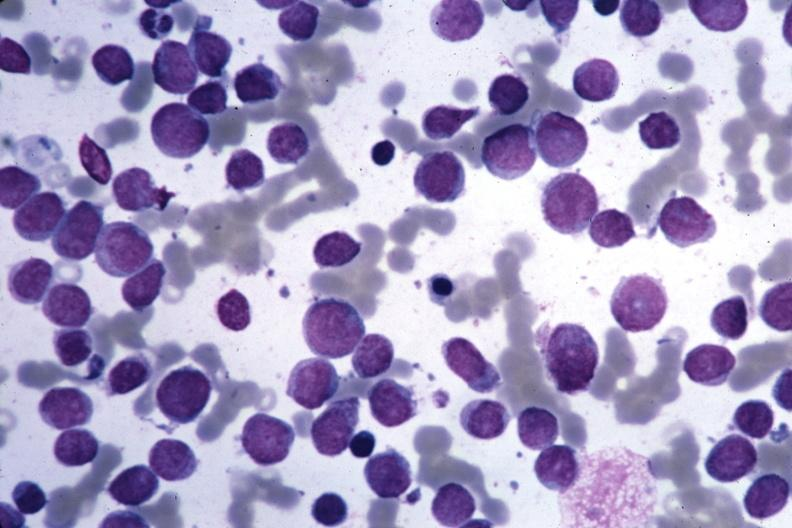what seen blastic cells?
Answer the question using a single word or phrase. Wrights 